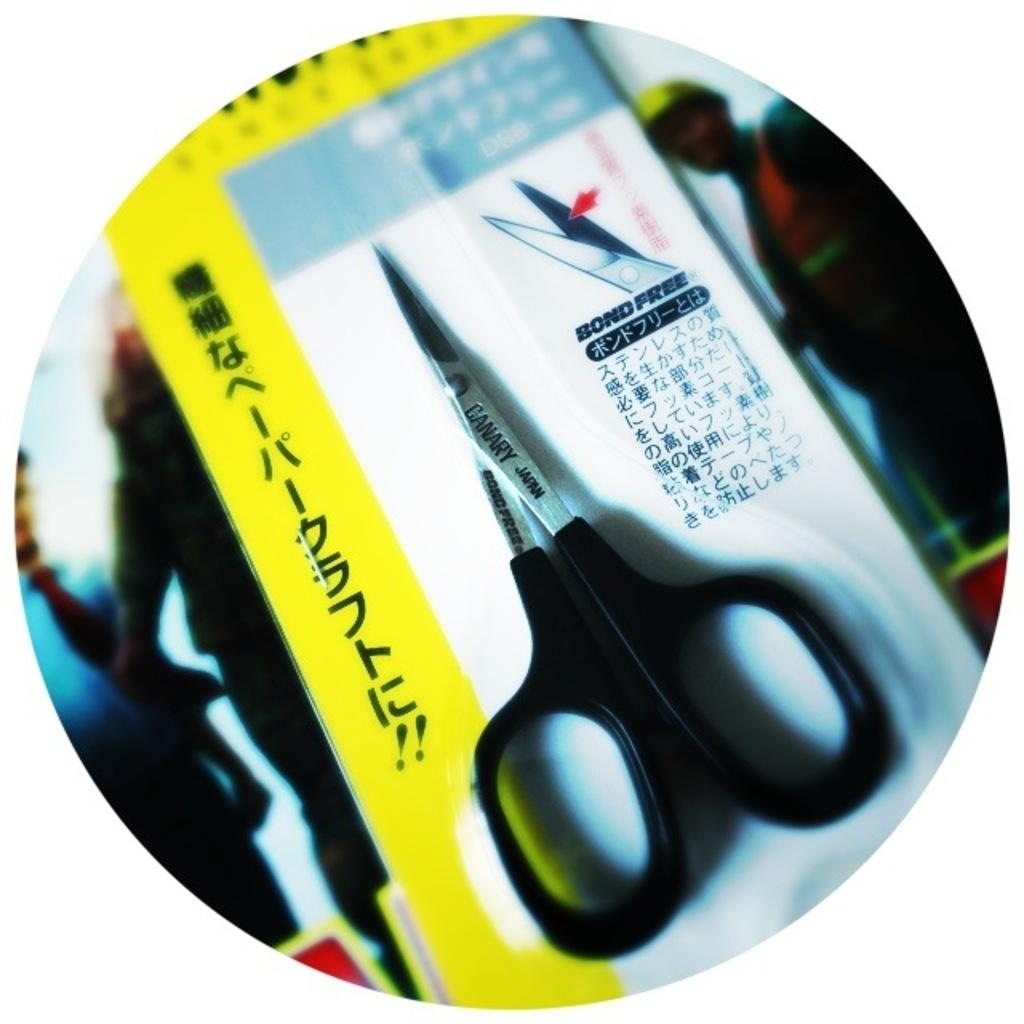What object is present in the image that is typically used for cutting? There are scissors in the image. What is the primary purpose of the card in the image? The card in the image is likely meant for communication or conveying a message, as it has text on it. Can you describe the picture in the background of the image? There is a picture of three persons in the background of the image. What type of disgusting substance can be seen dripping from the card in the image? There is no disgusting substance present in the image; the card has text on it and is not depicted as being damaged or affected by any substance. 